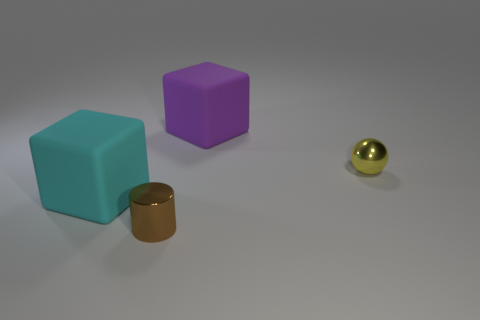Add 1 small brown metal cylinders. How many objects exist? 5 Subtract all spheres. How many objects are left? 3 Add 2 tiny spheres. How many tiny spheres exist? 3 Subtract 0 yellow cubes. How many objects are left? 4 Subtract all large objects. Subtract all green metal balls. How many objects are left? 2 Add 3 tiny yellow shiny objects. How many tiny yellow shiny objects are left? 4 